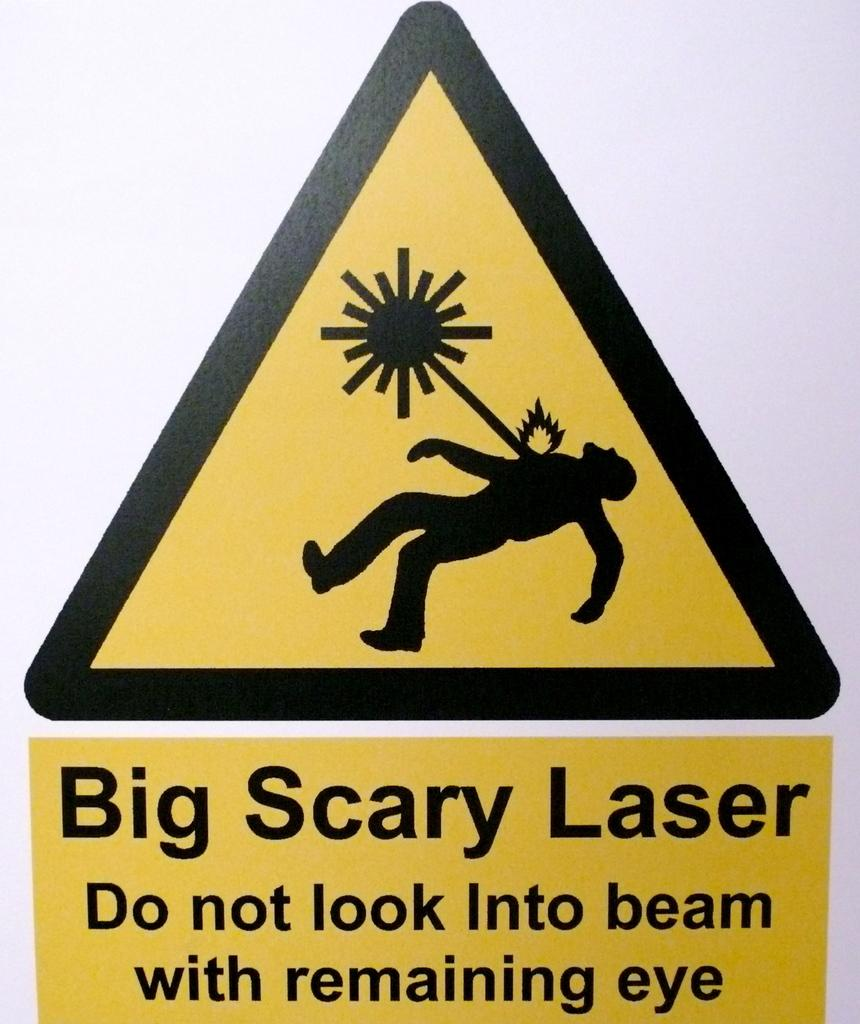<image>
Present a compact description of the photo's key features. A sign for a big scary laser shows someone being zapped. 